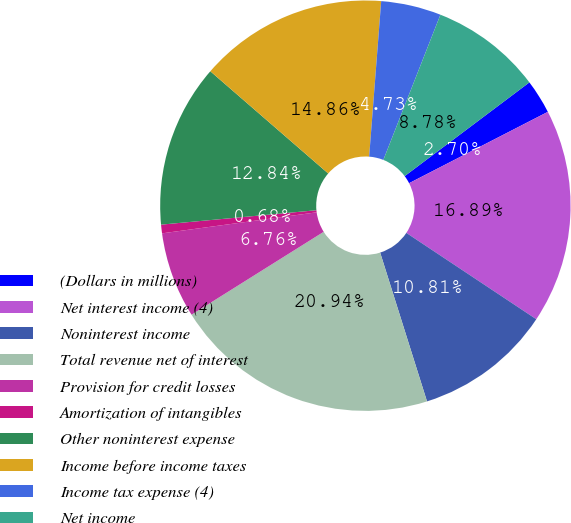Convert chart. <chart><loc_0><loc_0><loc_500><loc_500><pie_chart><fcel>(Dollars in millions)<fcel>Net interest income (4)<fcel>Noninterest income<fcel>Total revenue net of interest<fcel>Provision for credit losses<fcel>Amortization of intangibles<fcel>Other noninterest expense<fcel>Income before income taxes<fcel>Income tax expense (4)<fcel>Net income<nl><fcel>2.7%<fcel>16.89%<fcel>10.81%<fcel>20.94%<fcel>6.76%<fcel>0.68%<fcel>12.84%<fcel>14.86%<fcel>4.73%<fcel>8.78%<nl></chart> 